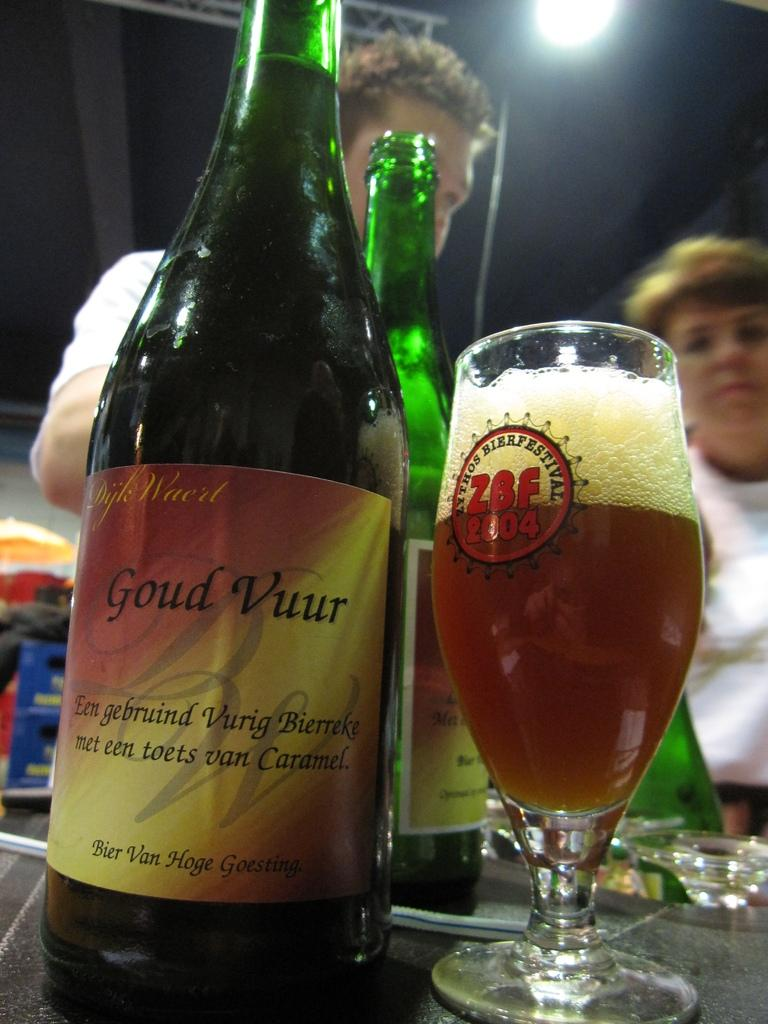What type of beverage is present in the image? There is a beer bottle and a glass of beer in the image. Where are these beverages located? They are on the table in the image. Are there any people visible in the image? Yes, two people are standing in the backdrop. How many flies are sitting on the beer bottle in the image? There are no flies present in the image; only a beer bottle and a glass of beer are visible on the table. 